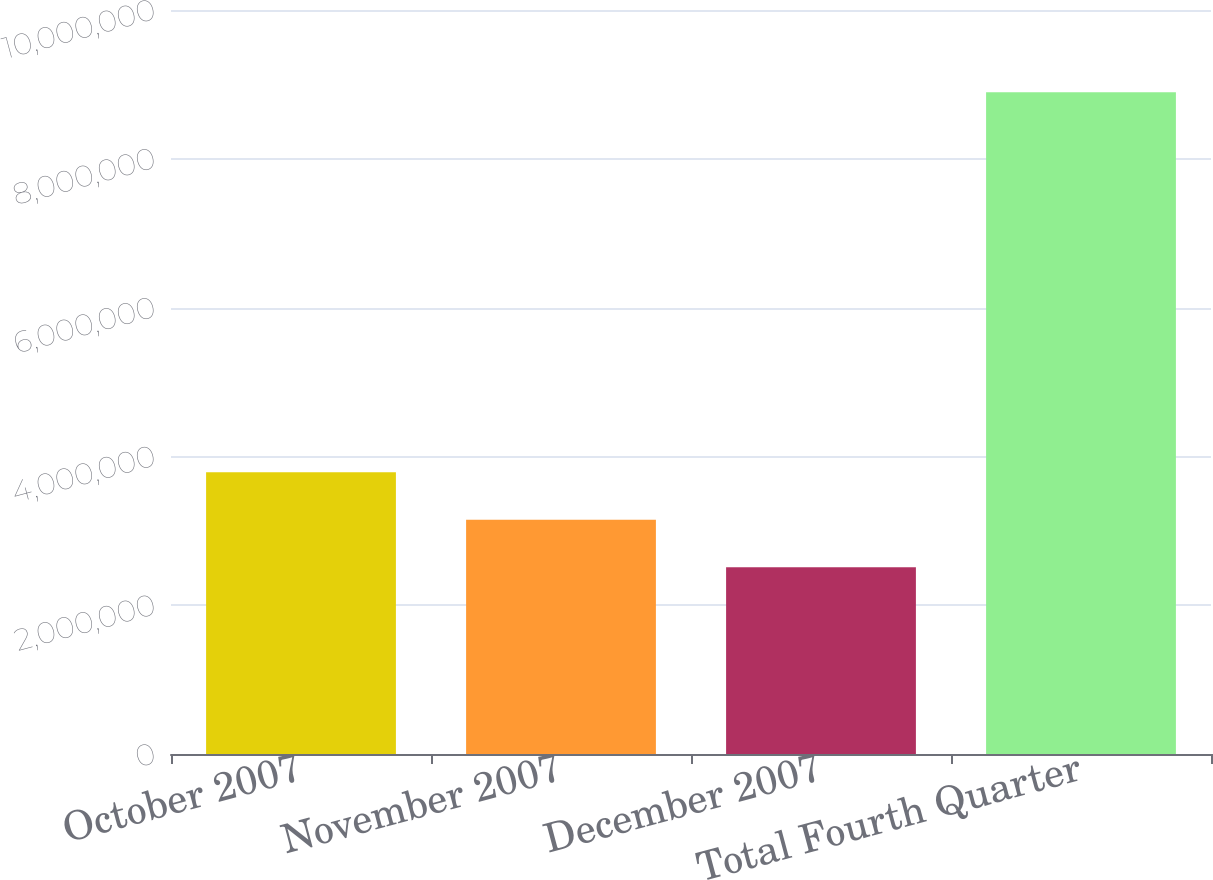Convert chart. <chart><loc_0><loc_0><loc_500><loc_500><bar_chart><fcel>October 2007<fcel>November 2007<fcel>December 2007<fcel>Total Fourth Quarter<nl><fcel>3.78745e+06<fcel>3.14894e+06<fcel>2.51042e+06<fcel>8.89557e+06<nl></chart> 